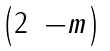<formula> <loc_0><loc_0><loc_500><loc_500>\begin{pmatrix} 2 & - m \end{pmatrix}</formula> 